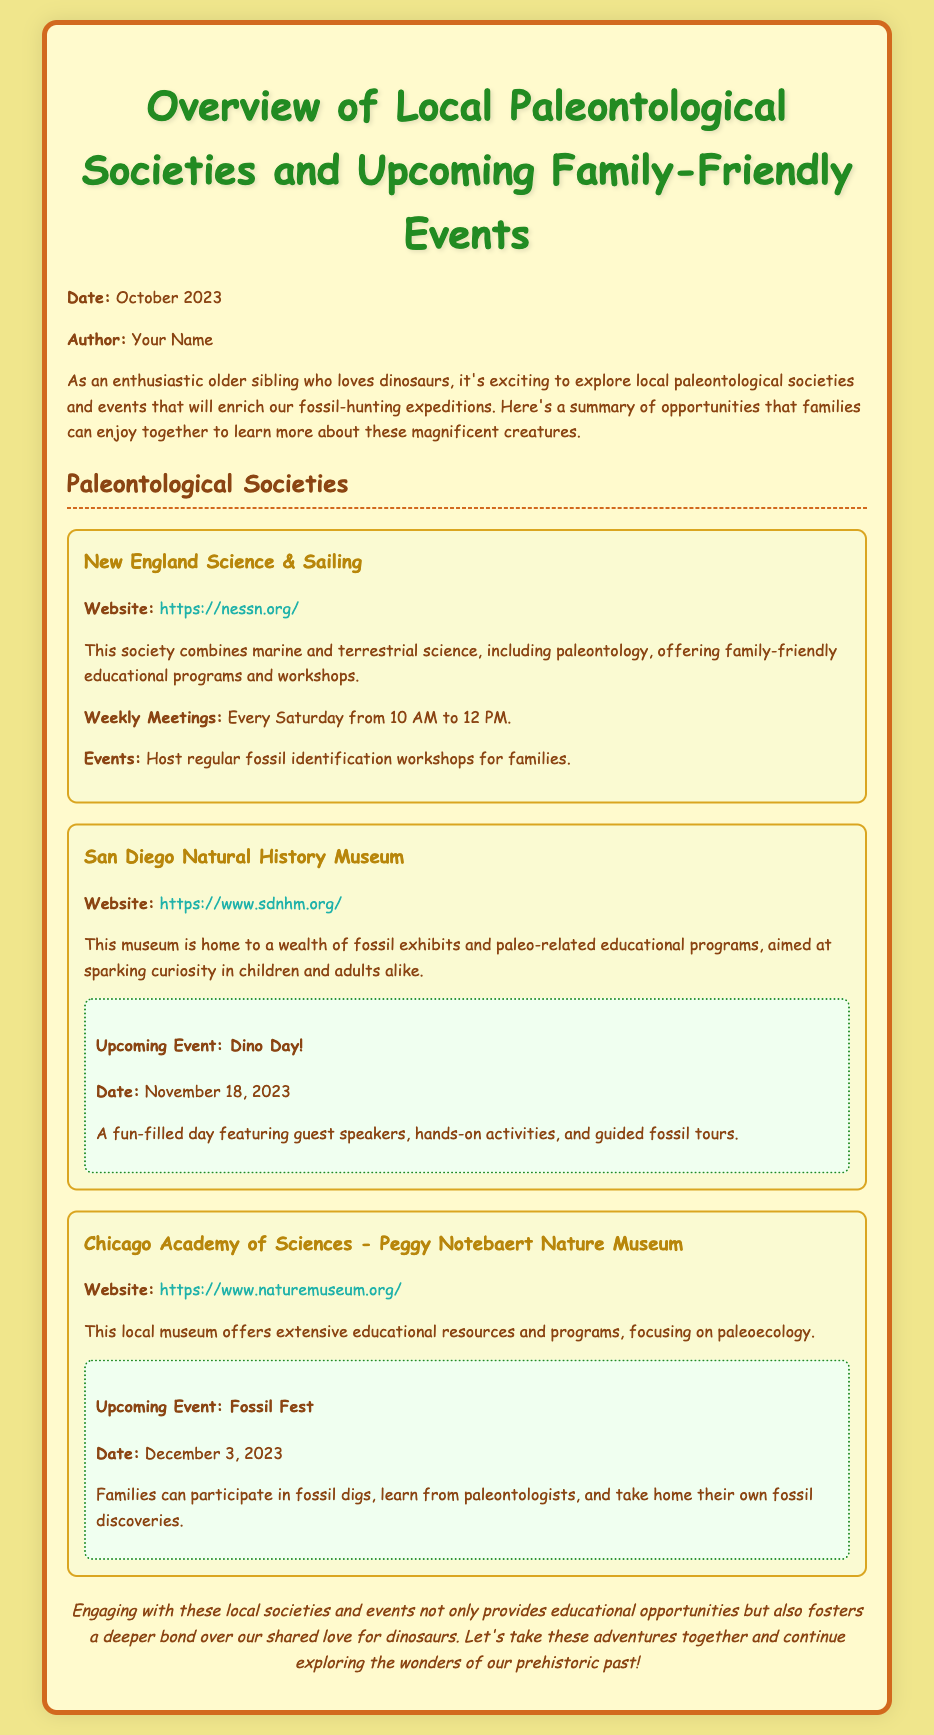What is the date of the upcoming Dino Day event? The date of the Dino Day event is mentioned in the document as November 18, 2023.
Answer: November 18, 2023 What society hosts fossil identification workshops? The document states that New England Science & Sailing hosts regular fossil identification workshops for families.
Answer: New England Science & Sailing How often do meetings occur at the New England Science & Sailing? The weekly meetings are noted as occurring every Saturday from 10 AM to 12 PM in the document.
Answer: Every Saturday What is the focus of the Chicago Academy of Sciences? The document indicates that the focus of the Chicago Academy of Sciences is on paleoecology.
Answer: Paleoecology What event is happening on December 3, 2023? The document provides information that on December 3, 2023, the event is called Fossil Fest.
Answer: Fossil Fest Which society is associated with a wealth of fossil exhibits? The San Diego Natural History Museum is noted for having a wealth of fossil exhibits, according to the document.
Answer: San Diego Natural History Museum What is a key activity during the Dino Day event? The key activity mentioned for the Dino Day event includes hands-on activities.
Answer: Hands-on activities What educational resources does the Peggy Notebaert Nature Museum offer? The document mentions that the museum offers extensive educational resources and programs.
Answer: Extensive educational resources 